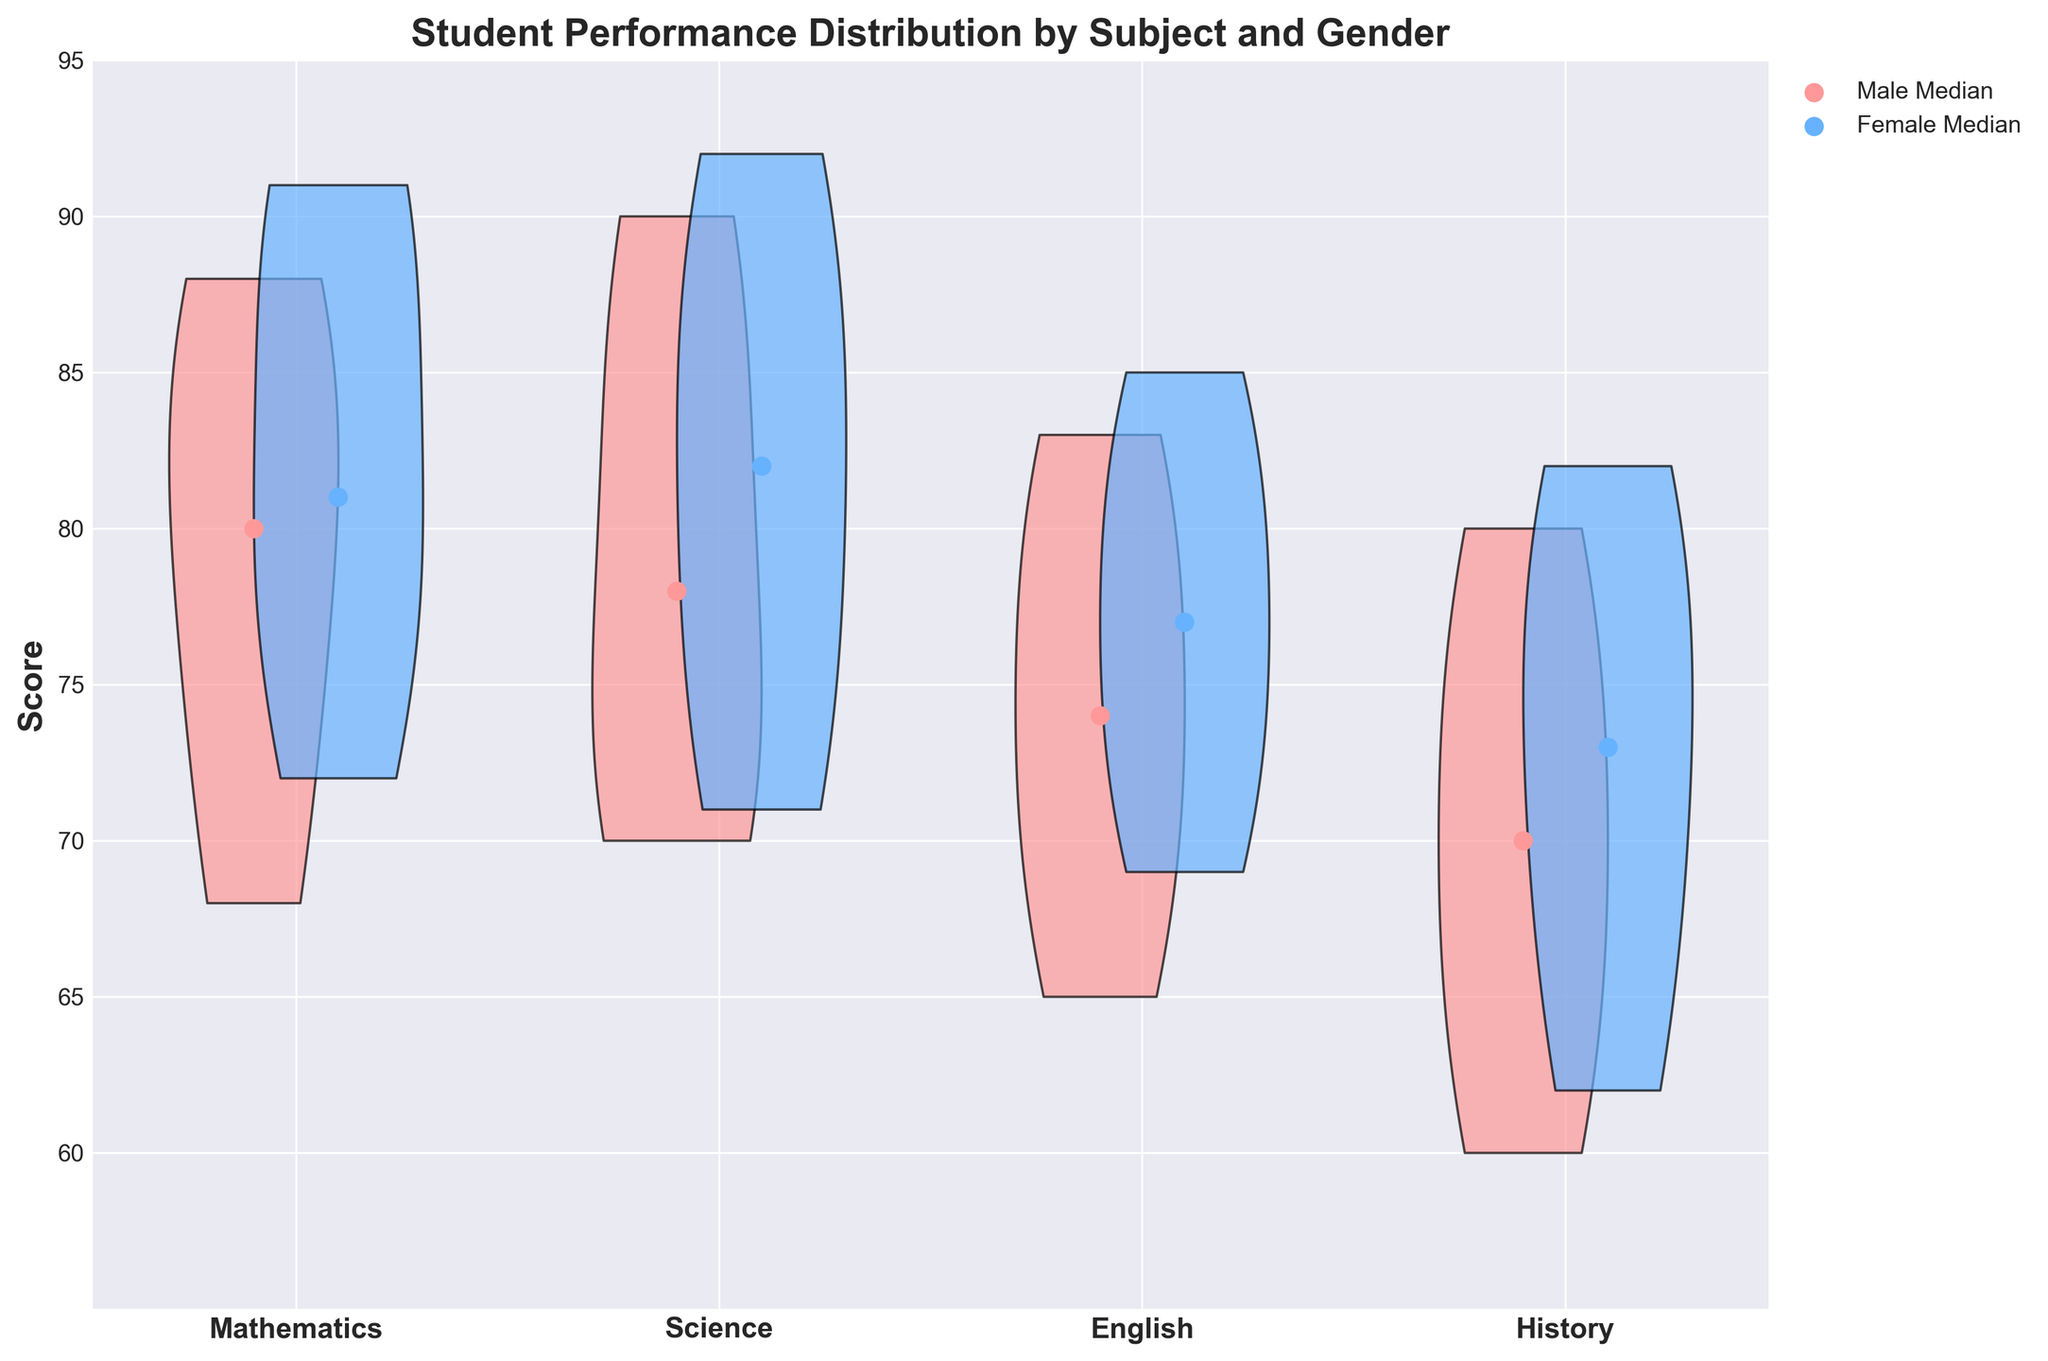What is the title of the figure? The title is located at the top of the figure and is written in bold letters.
Answer: Student Performance Distribution by Subject and Gender What are the labels on the x-axis? The labels on the x-axis represent the different subjects and are written in bold letters beneath the x-axis ticks
Answer: Mathematics, Science, English, History What is the range of scores displayed on the y-axis? The y-axis displays the score, with tick marks starting at 60 and ending at 95. The axis itself starts a bit below 60 and goes slightly above 95.
Answer: 60 to 95 Which subject shows the highest median score for females? To find the highest median score for females, look for the highest black dot/marker within the female violin plots. The highest dot indicates the highest median.
Answer: Science In which subject do males have a higher median score compared to females? Compare the positions of the black dots/markers for males and females within each subject. The subject where the male dot is higher than the female dot is the desired answer.
Answer: Science What color represents female scores on the violin plots? The colors of the violin plots are identifiable by their visual appearance. Female scores are represented by one of the two colors used.
Answer: #FF9999 (pink) What color represents male scores on the violin plots? The violin plots' colors can be identified visually, and male scores are represented by the other color used.
Answer: #66B2FF (blue) Which subject has the widest range of scores for males? To identify the widest range, look for the subject where the male violin plot appears the most spread out from top to bottom.
Answer: Mathematics Which subject shows a greater variability in scores for females? Variability in a violin plot is indicated by the spread of the shape. The subject where the female plot is widest vertically has the most variability.
Answer: Science Are there any subjects where the median scores for males and females are roughly the same? Compare the positions of the male and female median markers (black dots) across subjects. The subject where they are closest together provides the answer.
Answer: English 